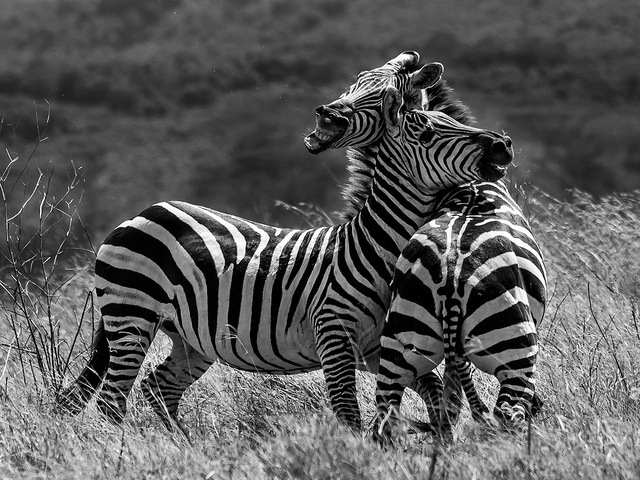Describe the objects in this image and their specific colors. I can see zebra in gray, black, darkgray, and lightgray tones and zebra in gray, black, darkgray, and lightgray tones in this image. 